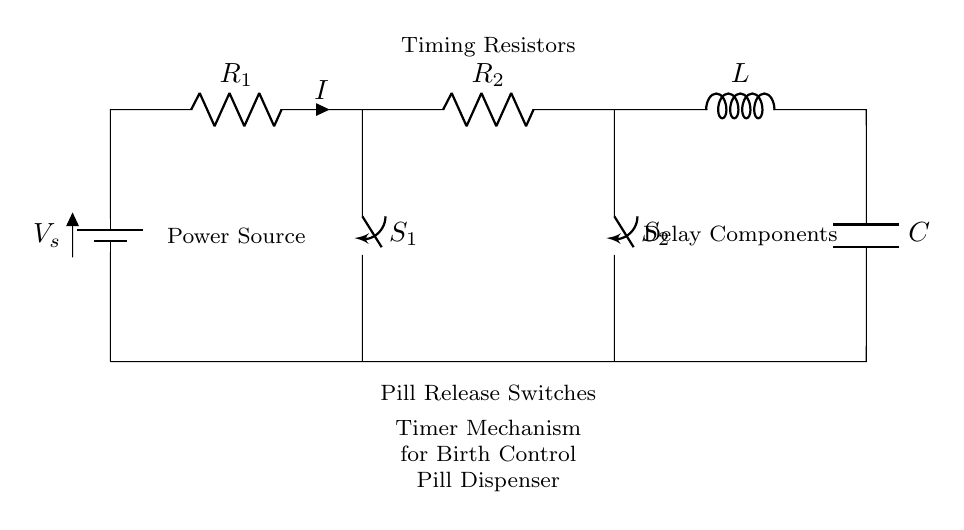What is the main power source in this circuit? The main power source is represented by the battery symbol, which provides the necessary voltage for the circuit to operate.
Answer: Battery What components are used for timing in this circuit? The timing in this circuit is achieved through the use of two resistors and a capacitor, which together form an RC timing circuit.
Answer: Resistors and capacitor What happens when switch S1 is closed? Closing switch S1 completes the circuit path allowing current to flow, which can activate the pill release mechanism connected to this path.
Answer: Current flows What is the role of the inductor in this circuit? The inductor acts as a delay component, helping to smooth or store energy in the circuit, which contributes to the timing functionality.
Answer: Delay How many resistors are present in the circuit? There are two resistors labeled R1 and R2 within the circuit diagram, which are essential for setting the timing intervals.
Answer: Two What are the potential consequences of opening switch S2? Opening switch S2 would break the circuit, stopping the current flow, and consequently preventing the pill dispensing mechanism from functioning.
Answer: Stops current flow What type of circuit is illustrated in this diagram? The circuit is a series circuit, as all components are connected end-to-end, allowing current to flow through each component sequentially.
Answer: Series circuit 